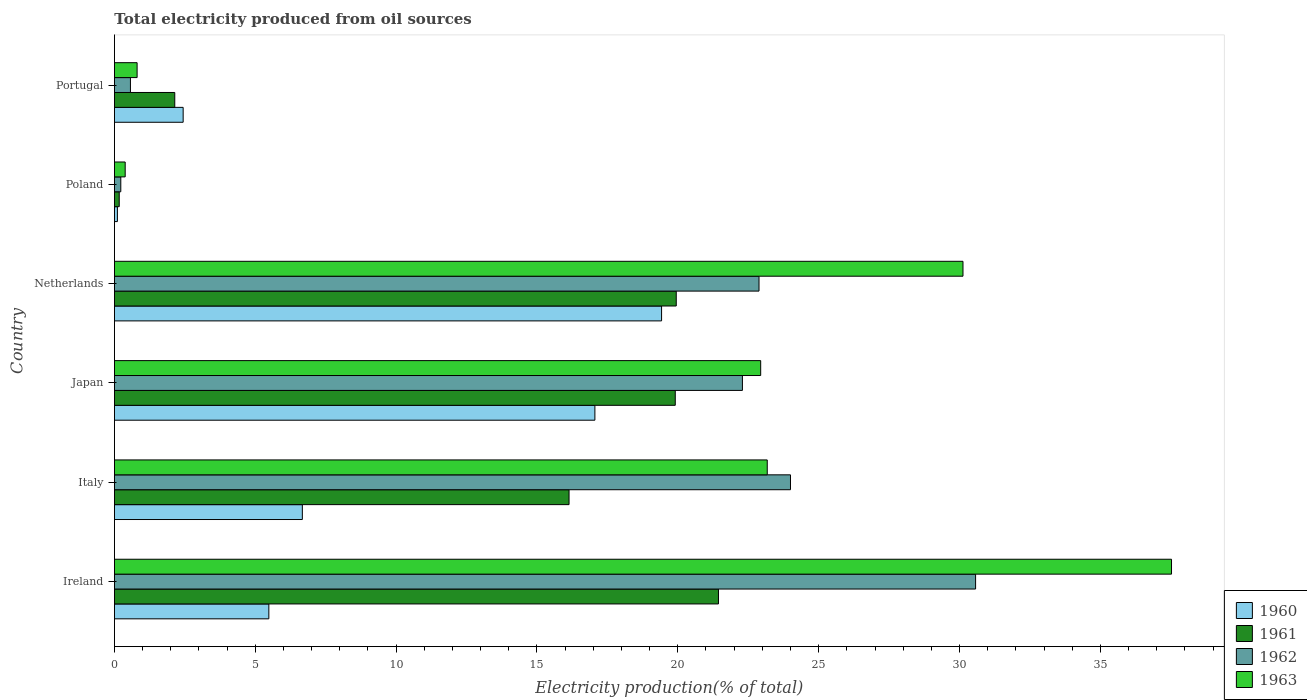How many different coloured bars are there?
Ensure brevity in your answer.  4. Are the number of bars on each tick of the Y-axis equal?
Ensure brevity in your answer.  Yes. What is the total electricity produced in 1962 in Ireland?
Ensure brevity in your answer.  30.57. Across all countries, what is the maximum total electricity produced in 1963?
Offer a very short reply. 37.53. Across all countries, what is the minimum total electricity produced in 1961?
Your answer should be compact. 0.17. In which country was the total electricity produced in 1962 maximum?
Give a very brief answer. Ireland. In which country was the total electricity produced in 1962 minimum?
Give a very brief answer. Poland. What is the total total electricity produced in 1963 in the graph?
Your response must be concise. 114.95. What is the difference between the total electricity produced in 1962 in Italy and that in Netherlands?
Offer a very short reply. 1.12. What is the difference between the total electricity produced in 1960 in Ireland and the total electricity produced in 1963 in Italy?
Offer a very short reply. -17.69. What is the average total electricity produced in 1961 per country?
Your response must be concise. 13.29. What is the difference between the total electricity produced in 1963 and total electricity produced in 1960 in Italy?
Give a very brief answer. 16.5. What is the ratio of the total electricity produced in 1961 in Ireland to that in Japan?
Keep it short and to the point. 1.08. What is the difference between the highest and the second highest total electricity produced in 1961?
Give a very brief answer. 1.5. What is the difference between the highest and the lowest total electricity produced in 1963?
Your response must be concise. 37.14. Is it the case that in every country, the sum of the total electricity produced in 1960 and total electricity produced in 1961 is greater than the total electricity produced in 1963?
Provide a short and direct response. No. How many bars are there?
Ensure brevity in your answer.  24. Are all the bars in the graph horizontal?
Provide a succinct answer. Yes. What is the difference between two consecutive major ticks on the X-axis?
Give a very brief answer. 5. How many legend labels are there?
Your response must be concise. 4. How are the legend labels stacked?
Your answer should be very brief. Vertical. What is the title of the graph?
Provide a short and direct response. Total electricity produced from oil sources. What is the Electricity production(% of total) of 1960 in Ireland?
Your answer should be very brief. 5.48. What is the Electricity production(% of total) in 1961 in Ireland?
Your answer should be very brief. 21.44. What is the Electricity production(% of total) in 1962 in Ireland?
Give a very brief answer. 30.57. What is the Electricity production(% of total) of 1963 in Ireland?
Offer a very short reply. 37.53. What is the Electricity production(% of total) in 1960 in Italy?
Keep it short and to the point. 6.67. What is the Electricity production(% of total) in 1961 in Italy?
Provide a succinct answer. 16.14. What is the Electricity production(% of total) of 1962 in Italy?
Ensure brevity in your answer.  24. What is the Electricity production(% of total) in 1963 in Italy?
Provide a succinct answer. 23.17. What is the Electricity production(% of total) in 1960 in Japan?
Make the answer very short. 17.06. What is the Electricity production(% of total) of 1961 in Japan?
Your answer should be compact. 19.91. What is the Electricity production(% of total) in 1962 in Japan?
Provide a short and direct response. 22.29. What is the Electricity production(% of total) of 1963 in Japan?
Provide a succinct answer. 22.94. What is the Electricity production(% of total) of 1960 in Netherlands?
Give a very brief answer. 19.42. What is the Electricity production(% of total) in 1961 in Netherlands?
Provide a short and direct response. 19.94. What is the Electricity production(% of total) in 1962 in Netherlands?
Offer a terse response. 22.88. What is the Electricity production(% of total) of 1963 in Netherlands?
Your answer should be very brief. 30.12. What is the Electricity production(% of total) in 1960 in Poland?
Make the answer very short. 0.11. What is the Electricity production(% of total) of 1961 in Poland?
Offer a very short reply. 0.17. What is the Electricity production(% of total) of 1962 in Poland?
Keep it short and to the point. 0.23. What is the Electricity production(% of total) of 1963 in Poland?
Offer a terse response. 0.38. What is the Electricity production(% of total) in 1960 in Portugal?
Your response must be concise. 2.44. What is the Electricity production(% of total) of 1961 in Portugal?
Keep it short and to the point. 2.14. What is the Electricity production(% of total) of 1962 in Portugal?
Your response must be concise. 0.57. What is the Electricity production(% of total) in 1963 in Portugal?
Offer a terse response. 0.81. Across all countries, what is the maximum Electricity production(% of total) of 1960?
Keep it short and to the point. 19.42. Across all countries, what is the maximum Electricity production(% of total) of 1961?
Your answer should be compact. 21.44. Across all countries, what is the maximum Electricity production(% of total) of 1962?
Ensure brevity in your answer.  30.57. Across all countries, what is the maximum Electricity production(% of total) in 1963?
Keep it short and to the point. 37.53. Across all countries, what is the minimum Electricity production(% of total) in 1960?
Offer a terse response. 0.11. Across all countries, what is the minimum Electricity production(% of total) in 1961?
Your answer should be compact. 0.17. Across all countries, what is the minimum Electricity production(% of total) in 1962?
Provide a succinct answer. 0.23. Across all countries, what is the minimum Electricity production(% of total) of 1963?
Your answer should be compact. 0.38. What is the total Electricity production(% of total) in 1960 in the graph?
Ensure brevity in your answer.  51.18. What is the total Electricity production(% of total) of 1961 in the graph?
Provide a succinct answer. 79.75. What is the total Electricity production(% of total) in 1962 in the graph?
Your response must be concise. 100.54. What is the total Electricity production(% of total) in 1963 in the graph?
Provide a succinct answer. 114.95. What is the difference between the Electricity production(% of total) in 1960 in Ireland and that in Italy?
Give a very brief answer. -1.19. What is the difference between the Electricity production(% of total) in 1961 in Ireland and that in Italy?
Provide a short and direct response. 5.3. What is the difference between the Electricity production(% of total) in 1962 in Ireland and that in Italy?
Your answer should be compact. 6.57. What is the difference between the Electricity production(% of total) in 1963 in Ireland and that in Italy?
Make the answer very short. 14.35. What is the difference between the Electricity production(% of total) in 1960 in Ireland and that in Japan?
Offer a very short reply. -11.57. What is the difference between the Electricity production(% of total) in 1961 in Ireland and that in Japan?
Make the answer very short. 1.53. What is the difference between the Electricity production(% of total) in 1962 in Ireland and that in Japan?
Offer a very short reply. 8.28. What is the difference between the Electricity production(% of total) in 1963 in Ireland and that in Japan?
Your response must be concise. 14.58. What is the difference between the Electricity production(% of total) in 1960 in Ireland and that in Netherlands?
Provide a short and direct response. -13.94. What is the difference between the Electricity production(% of total) in 1961 in Ireland and that in Netherlands?
Offer a very short reply. 1.5. What is the difference between the Electricity production(% of total) in 1962 in Ireland and that in Netherlands?
Your response must be concise. 7.69. What is the difference between the Electricity production(% of total) in 1963 in Ireland and that in Netherlands?
Make the answer very short. 7.4. What is the difference between the Electricity production(% of total) of 1960 in Ireland and that in Poland?
Provide a short and direct response. 5.38. What is the difference between the Electricity production(% of total) of 1961 in Ireland and that in Poland?
Your answer should be compact. 21.27. What is the difference between the Electricity production(% of total) in 1962 in Ireland and that in Poland?
Make the answer very short. 30.34. What is the difference between the Electricity production(% of total) in 1963 in Ireland and that in Poland?
Offer a terse response. 37.14. What is the difference between the Electricity production(% of total) in 1960 in Ireland and that in Portugal?
Offer a terse response. 3.04. What is the difference between the Electricity production(% of total) in 1961 in Ireland and that in Portugal?
Make the answer very short. 19.3. What is the difference between the Electricity production(% of total) in 1962 in Ireland and that in Portugal?
Offer a very short reply. 30. What is the difference between the Electricity production(% of total) of 1963 in Ireland and that in Portugal?
Your response must be concise. 36.72. What is the difference between the Electricity production(% of total) in 1960 in Italy and that in Japan?
Your answer should be very brief. -10.39. What is the difference between the Electricity production(% of total) in 1961 in Italy and that in Japan?
Keep it short and to the point. -3.77. What is the difference between the Electricity production(% of total) in 1962 in Italy and that in Japan?
Ensure brevity in your answer.  1.71. What is the difference between the Electricity production(% of total) of 1963 in Italy and that in Japan?
Your answer should be very brief. 0.23. What is the difference between the Electricity production(% of total) in 1960 in Italy and that in Netherlands?
Your answer should be compact. -12.75. What is the difference between the Electricity production(% of total) in 1961 in Italy and that in Netherlands?
Provide a short and direct response. -3.81. What is the difference between the Electricity production(% of total) of 1962 in Italy and that in Netherlands?
Provide a succinct answer. 1.12. What is the difference between the Electricity production(% of total) of 1963 in Italy and that in Netherlands?
Provide a succinct answer. -6.95. What is the difference between the Electricity production(% of total) in 1960 in Italy and that in Poland?
Give a very brief answer. 6.57. What is the difference between the Electricity production(% of total) of 1961 in Italy and that in Poland?
Provide a short and direct response. 15.97. What is the difference between the Electricity production(% of total) in 1962 in Italy and that in Poland?
Your answer should be very brief. 23.77. What is the difference between the Electricity production(% of total) in 1963 in Italy and that in Poland?
Give a very brief answer. 22.79. What is the difference between the Electricity production(% of total) in 1960 in Italy and that in Portugal?
Your answer should be compact. 4.23. What is the difference between the Electricity production(% of total) of 1961 in Italy and that in Portugal?
Your answer should be compact. 14. What is the difference between the Electricity production(% of total) in 1962 in Italy and that in Portugal?
Your response must be concise. 23.43. What is the difference between the Electricity production(% of total) in 1963 in Italy and that in Portugal?
Provide a short and direct response. 22.37. What is the difference between the Electricity production(% of total) of 1960 in Japan and that in Netherlands?
Your answer should be very brief. -2.37. What is the difference between the Electricity production(% of total) in 1961 in Japan and that in Netherlands?
Make the answer very short. -0.04. What is the difference between the Electricity production(% of total) in 1962 in Japan and that in Netherlands?
Your answer should be compact. -0.59. What is the difference between the Electricity production(% of total) in 1963 in Japan and that in Netherlands?
Your answer should be compact. -7.18. What is the difference between the Electricity production(% of total) in 1960 in Japan and that in Poland?
Make the answer very short. 16.95. What is the difference between the Electricity production(% of total) in 1961 in Japan and that in Poland?
Provide a short and direct response. 19.74. What is the difference between the Electricity production(% of total) in 1962 in Japan and that in Poland?
Offer a very short reply. 22.07. What is the difference between the Electricity production(% of total) of 1963 in Japan and that in Poland?
Provide a short and direct response. 22.56. What is the difference between the Electricity production(% of total) of 1960 in Japan and that in Portugal?
Give a very brief answer. 14.62. What is the difference between the Electricity production(% of total) in 1961 in Japan and that in Portugal?
Make the answer very short. 17.77. What is the difference between the Electricity production(% of total) of 1962 in Japan and that in Portugal?
Provide a succinct answer. 21.73. What is the difference between the Electricity production(% of total) in 1963 in Japan and that in Portugal?
Your response must be concise. 22.14. What is the difference between the Electricity production(% of total) of 1960 in Netherlands and that in Poland?
Provide a short and direct response. 19.32. What is the difference between the Electricity production(% of total) of 1961 in Netherlands and that in Poland?
Provide a succinct answer. 19.77. What is the difference between the Electricity production(% of total) of 1962 in Netherlands and that in Poland?
Your response must be concise. 22.66. What is the difference between the Electricity production(% of total) of 1963 in Netherlands and that in Poland?
Offer a terse response. 29.74. What is the difference between the Electricity production(% of total) in 1960 in Netherlands and that in Portugal?
Your response must be concise. 16.98. What is the difference between the Electricity production(% of total) in 1961 in Netherlands and that in Portugal?
Provide a succinct answer. 17.8. What is the difference between the Electricity production(% of total) of 1962 in Netherlands and that in Portugal?
Your response must be concise. 22.31. What is the difference between the Electricity production(% of total) in 1963 in Netherlands and that in Portugal?
Keep it short and to the point. 29.32. What is the difference between the Electricity production(% of total) in 1960 in Poland and that in Portugal?
Make the answer very short. -2.33. What is the difference between the Electricity production(% of total) in 1961 in Poland and that in Portugal?
Your answer should be compact. -1.97. What is the difference between the Electricity production(% of total) in 1962 in Poland and that in Portugal?
Make the answer very short. -0.34. What is the difference between the Electricity production(% of total) in 1963 in Poland and that in Portugal?
Offer a very short reply. -0.42. What is the difference between the Electricity production(% of total) in 1960 in Ireland and the Electricity production(% of total) in 1961 in Italy?
Offer a terse response. -10.66. What is the difference between the Electricity production(% of total) in 1960 in Ireland and the Electricity production(% of total) in 1962 in Italy?
Offer a very short reply. -18.52. What is the difference between the Electricity production(% of total) of 1960 in Ireland and the Electricity production(% of total) of 1963 in Italy?
Ensure brevity in your answer.  -17.69. What is the difference between the Electricity production(% of total) of 1961 in Ireland and the Electricity production(% of total) of 1962 in Italy?
Offer a terse response. -2.56. What is the difference between the Electricity production(% of total) in 1961 in Ireland and the Electricity production(% of total) in 1963 in Italy?
Your answer should be very brief. -1.73. What is the difference between the Electricity production(% of total) of 1962 in Ireland and the Electricity production(% of total) of 1963 in Italy?
Provide a short and direct response. 7.4. What is the difference between the Electricity production(% of total) of 1960 in Ireland and the Electricity production(% of total) of 1961 in Japan?
Your answer should be very brief. -14.43. What is the difference between the Electricity production(% of total) in 1960 in Ireland and the Electricity production(% of total) in 1962 in Japan?
Offer a terse response. -16.81. What is the difference between the Electricity production(% of total) in 1960 in Ireland and the Electricity production(% of total) in 1963 in Japan?
Ensure brevity in your answer.  -17.46. What is the difference between the Electricity production(% of total) in 1961 in Ireland and the Electricity production(% of total) in 1962 in Japan?
Provide a short and direct response. -0.85. What is the difference between the Electricity production(% of total) in 1961 in Ireland and the Electricity production(% of total) in 1963 in Japan?
Give a very brief answer. -1.5. What is the difference between the Electricity production(% of total) in 1962 in Ireland and the Electricity production(% of total) in 1963 in Japan?
Give a very brief answer. 7.63. What is the difference between the Electricity production(% of total) of 1960 in Ireland and the Electricity production(% of total) of 1961 in Netherlands?
Keep it short and to the point. -14.46. What is the difference between the Electricity production(% of total) in 1960 in Ireland and the Electricity production(% of total) in 1962 in Netherlands?
Offer a very short reply. -17.4. What is the difference between the Electricity production(% of total) in 1960 in Ireland and the Electricity production(% of total) in 1963 in Netherlands?
Ensure brevity in your answer.  -24.64. What is the difference between the Electricity production(% of total) of 1961 in Ireland and the Electricity production(% of total) of 1962 in Netherlands?
Your response must be concise. -1.44. What is the difference between the Electricity production(% of total) in 1961 in Ireland and the Electricity production(% of total) in 1963 in Netherlands?
Your response must be concise. -8.68. What is the difference between the Electricity production(% of total) in 1962 in Ireland and the Electricity production(% of total) in 1963 in Netherlands?
Make the answer very short. 0.45. What is the difference between the Electricity production(% of total) of 1960 in Ireland and the Electricity production(% of total) of 1961 in Poland?
Make the answer very short. 5.31. What is the difference between the Electricity production(% of total) of 1960 in Ireland and the Electricity production(% of total) of 1962 in Poland?
Provide a succinct answer. 5.26. What is the difference between the Electricity production(% of total) of 1960 in Ireland and the Electricity production(% of total) of 1963 in Poland?
Offer a very short reply. 5.1. What is the difference between the Electricity production(% of total) in 1961 in Ireland and the Electricity production(% of total) in 1962 in Poland?
Your response must be concise. 21.22. What is the difference between the Electricity production(% of total) in 1961 in Ireland and the Electricity production(% of total) in 1963 in Poland?
Make the answer very short. 21.06. What is the difference between the Electricity production(% of total) of 1962 in Ireland and the Electricity production(% of total) of 1963 in Poland?
Your answer should be compact. 30.19. What is the difference between the Electricity production(% of total) of 1960 in Ireland and the Electricity production(% of total) of 1961 in Portugal?
Make the answer very short. 3.34. What is the difference between the Electricity production(% of total) in 1960 in Ireland and the Electricity production(% of total) in 1962 in Portugal?
Keep it short and to the point. 4.91. What is the difference between the Electricity production(% of total) of 1960 in Ireland and the Electricity production(% of total) of 1963 in Portugal?
Give a very brief answer. 4.68. What is the difference between the Electricity production(% of total) of 1961 in Ireland and the Electricity production(% of total) of 1962 in Portugal?
Ensure brevity in your answer.  20.87. What is the difference between the Electricity production(% of total) in 1961 in Ireland and the Electricity production(% of total) in 1963 in Portugal?
Provide a short and direct response. 20.64. What is the difference between the Electricity production(% of total) in 1962 in Ireland and the Electricity production(% of total) in 1963 in Portugal?
Your answer should be very brief. 29.77. What is the difference between the Electricity production(% of total) in 1960 in Italy and the Electricity production(% of total) in 1961 in Japan?
Your response must be concise. -13.24. What is the difference between the Electricity production(% of total) of 1960 in Italy and the Electricity production(% of total) of 1962 in Japan?
Offer a very short reply. -15.62. What is the difference between the Electricity production(% of total) of 1960 in Italy and the Electricity production(% of total) of 1963 in Japan?
Provide a short and direct response. -16.27. What is the difference between the Electricity production(% of total) in 1961 in Italy and the Electricity production(% of total) in 1962 in Japan?
Provide a short and direct response. -6.15. What is the difference between the Electricity production(% of total) in 1961 in Italy and the Electricity production(% of total) in 1963 in Japan?
Your answer should be very brief. -6.8. What is the difference between the Electricity production(% of total) in 1962 in Italy and the Electricity production(% of total) in 1963 in Japan?
Provide a succinct answer. 1.06. What is the difference between the Electricity production(% of total) in 1960 in Italy and the Electricity production(% of total) in 1961 in Netherlands?
Give a very brief answer. -13.27. What is the difference between the Electricity production(% of total) of 1960 in Italy and the Electricity production(% of total) of 1962 in Netherlands?
Your answer should be very brief. -16.21. What is the difference between the Electricity production(% of total) of 1960 in Italy and the Electricity production(% of total) of 1963 in Netherlands?
Ensure brevity in your answer.  -23.45. What is the difference between the Electricity production(% of total) of 1961 in Italy and the Electricity production(% of total) of 1962 in Netherlands?
Provide a short and direct response. -6.74. What is the difference between the Electricity production(% of total) in 1961 in Italy and the Electricity production(% of total) in 1963 in Netherlands?
Your answer should be very brief. -13.98. What is the difference between the Electricity production(% of total) of 1962 in Italy and the Electricity production(% of total) of 1963 in Netherlands?
Your response must be concise. -6.12. What is the difference between the Electricity production(% of total) of 1960 in Italy and the Electricity production(% of total) of 1961 in Poland?
Make the answer very short. 6.5. What is the difference between the Electricity production(% of total) of 1960 in Italy and the Electricity production(% of total) of 1962 in Poland?
Keep it short and to the point. 6.44. What is the difference between the Electricity production(% of total) in 1960 in Italy and the Electricity production(% of total) in 1963 in Poland?
Provide a succinct answer. 6.29. What is the difference between the Electricity production(% of total) of 1961 in Italy and the Electricity production(% of total) of 1962 in Poland?
Ensure brevity in your answer.  15.91. What is the difference between the Electricity production(% of total) of 1961 in Italy and the Electricity production(% of total) of 1963 in Poland?
Ensure brevity in your answer.  15.76. What is the difference between the Electricity production(% of total) in 1962 in Italy and the Electricity production(% of total) in 1963 in Poland?
Your answer should be very brief. 23.62. What is the difference between the Electricity production(% of total) in 1960 in Italy and the Electricity production(% of total) in 1961 in Portugal?
Your answer should be very brief. 4.53. What is the difference between the Electricity production(% of total) in 1960 in Italy and the Electricity production(% of total) in 1962 in Portugal?
Your answer should be compact. 6.1. What is the difference between the Electricity production(% of total) of 1960 in Italy and the Electricity production(% of total) of 1963 in Portugal?
Provide a short and direct response. 5.87. What is the difference between the Electricity production(% of total) of 1961 in Italy and the Electricity production(% of total) of 1962 in Portugal?
Give a very brief answer. 15.57. What is the difference between the Electricity production(% of total) in 1961 in Italy and the Electricity production(% of total) in 1963 in Portugal?
Make the answer very short. 15.33. What is the difference between the Electricity production(% of total) in 1962 in Italy and the Electricity production(% of total) in 1963 in Portugal?
Provide a short and direct response. 23.19. What is the difference between the Electricity production(% of total) in 1960 in Japan and the Electricity production(% of total) in 1961 in Netherlands?
Provide a short and direct response. -2.89. What is the difference between the Electricity production(% of total) of 1960 in Japan and the Electricity production(% of total) of 1962 in Netherlands?
Ensure brevity in your answer.  -5.83. What is the difference between the Electricity production(% of total) of 1960 in Japan and the Electricity production(% of total) of 1963 in Netherlands?
Your response must be concise. -13.07. What is the difference between the Electricity production(% of total) of 1961 in Japan and the Electricity production(% of total) of 1962 in Netherlands?
Provide a succinct answer. -2.97. What is the difference between the Electricity production(% of total) of 1961 in Japan and the Electricity production(% of total) of 1963 in Netherlands?
Make the answer very short. -10.21. What is the difference between the Electricity production(% of total) of 1962 in Japan and the Electricity production(% of total) of 1963 in Netherlands?
Your answer should be compact. -7.83. What is the difference between the Electricity production(% of total) of 1960 in Japan and the Electricity production(% of total) of 1961 in Poland?
Make the answer very short. 16.89. What is the difference between the Electricity production(% of total) in 1960 in Japan and the Electricity production(% of total) in 1962 in Poland?
Provide a succinct answer. 16.83. What is the difference between the Electricity production(% of total) of 1960 in Japan and the Electricity production(% of total) of 1963 in Poland?
Your answer should be compact. 16.67. What is the difference between the Electricity production(% of total) of 1961 in Japan and the Electricity production(% of total) of 1962 in Poland?
Your response must be concise. 19.68. What is the difference between the Electricity production(% of total) in 1961 in Japan and the Electricity production(% of total) in 1963 in Poland?
Offer a very short reply. 19.53. What is the difference between the Electricity production(% of total) of 1962 in Japan and the Electricity production(% of total) of 1963 in Poland?
Make the answer very short. 21.91. What is the difference between the Electricity production(% of total) in 1960 in Japan and the Electricity production(% of total) in 1961 in Portugal?
Your answer should be compact. 14.91. What is the difference between the Electricity production(% of total) of 1960 in Japan and the Electricity production(% of total) of 1962 in Portugal?
Offer a very short reply. 16.49. What is the difference between the Electricity production(% of total) in 1960 in Japan and the Electricity production(% of total) in 1963 in Portugal?
Your response must be concise. 16.25. What is the difference between the Electricity production(% of total) of 1961 in Japan and the Electricity production(% of total) of 1962 in Portugal?
Provide a short and direct response. 19.34. What is the difference between the Electricity production(% of total) in 1961 in Japan and the Electricity production(% of total) in 1963 in Portugal?
Provide a short and direct response. 19.1. What is the difference between the Electricity production(% of total) of 1962 in Japan and the Electricity production(% of total) of 1963 in Portugal?
Your answer should be compact. 21.49. What is the difference between the Electricity production(% of total) in 1960 in Netherlands and the Electricity production(% of total) in 1961 in Poland?
Ensure brevity in your answer.  19.25. What is the difference between the Electricity production(% of total) of 1960 in Netherlands and the Electricity production(% of total) of 1962 in Poland?
Your answer should be very brief. 19.2. What is the difference between the Electricity production(% of total) in 1960 in Netherlands and the Electricity production(% of total) in 1963 in Poland?
Offer a very short reply. 19.04. What is the difference between the Electricity production(% of total) in 1961 in Netherlands and the Electricity production(% of total) in 1962 in Poland?
Give a very brief answer. 19.72. What is the difference between the Electricity production(% of total) in 1961 in Netherlands and the Electricity production(% of total) in 1963 in Poland?
Your answer should be compact. 19.56. What is the difference between the Electricity production(% of total) in 1962 in Netherlands and the Electricity production(% of total) in 1963 in Poland?
Ensure brevity in your answer.  22.5. What is the difference between the Electricity production(% of total) of 1960 in Netherlands and the Electricity production(% of total) of 1961 in Portugal?
Give a very brief answer. 17.28. What is the difference between the Electricity production(% of total) in 1960 in Netherlands and the Electricity production(% of total) in 1962 in Portugal?
Provide a succinct answer. 18.86. What is the difference between the Electricity production(% of total) in 1960 in Netherlands and the Electricity production(% of total) in 1963 in Portugal?
Provide a short and direct response. 18.62. What is the difference between the Electricity production(% of total) in 1961 in Netherlands and the Electricity production(% of total) in 1962 in Portugal?
Make the answer very short. 19.38. What is the difference between the Electricity production(% of total) of 1961 in Netherlands and the Electricity production(% of total) of 1963 in Portugal?
Provide a succinct answer. 19.14. What is the difference between the Electricity production(% of total) of 1962 in Netherlands and the Electricity production(% of total) of 1963 in Portugal?
Provide a succinct answer. 22.08. What is the difference between the Electricity production(% of total) of 1960 in Poland and the Electricity production(% of total) of 1961 in Portugal?
Provide a short and direct response. -2.04. What is the difference between the Electricity production(% of total) in 1960 in Poland and the Electricity production(% of total) in 1962 in Portugal?
Your response must be concise. -0.46. What is the difference between the Electricity production(% of total) in 1960 in Poland and the Electricity production(% of total) in 1963 in Portugal?
Give a very brief answer. -0.7. What is the difference between the Electricity production(% of total) in 1961 in Poland and the Electricity production(% of total) in 1962 in Portugal?
Keep it short and to the point. -0.4. What is the difference between the Electricity production(% of total) of 1961 in Poland and the Electricity production(% of total) of 1963 in Portugal?
Your response must be concise. -0.63. What is the difference between the Electricity production(% of total) of 1962 in Poland and the Electricity production(% of total) of 1963 in Portugal?
Ensure brevity in your answer.  -0.58. What is the average Electricity production(% of total) of 1960 per country?
Give a very brief answer. 8.53. What is the average Electricity production(% of total) in 1961 per country?
Ensure brevity in your answer.  13.29. What is the average Electricity production(% of total) of 1962 per country?
Keep it short and to the point. 16.76. What is the average Electricity production(% of total) of 1963 per country?
Give a very brief answer. 19.16. What is the difference between the Electricity production(% of total) in 1960 and Electricity production(% of total) in 1961 in Ireland?
Give a very brief answer. -15.96. What is the difference between the Electricity production(% of total) in 1960 and Electricity production(% of total) in 1962 in Ireland?
Keep it short and to the point. -25.09. What is the difference between the Electricity production(% of total) of 1960 and Electricity production(% of total) of 1963 in Ireland?
Provide a short and direct response. -32.04. What is the difference between the Electricity production(% of total) in 1961 and Electricity production(% of total) in 1962 in Ireland?
Provide a succinct answer. -9.13. What is the difference between the Electricity production(% of total) of 1961 and Electricity production(% of total) of 1963 in Ireland?
Your answer should be compact. -16.08. What is the difference between the Electricity production(% of total) of 1962 and Electricity production(% of total) of 1963 in Ireland?
Provide a succinct answer. -6.95. What is the difference between the Electricity production(% of total) of 1960 and Electricity production(% of total) of 1961 in Italy?
Offer a very short reply. -9.47. What is the difference between the Electricity production(% of total) in 1960 and Electricity production(% of total) in 1962 in Italy?
Keep it short and to the point. -17.33. What is the difference between the Electricity production(% of total) in 1960 and Electricity production(% of total) in 1963 in Italy?
Make the answer very short. -16.5. What is the difference between the Electricity production(% of total) in 1961 and Electricity production(% of total) in 1962 in Italy?
Your response must be concise. -7.86. What is the difference between the Electricity production(% of total) in 1961 and Electricity production(% of total) in 1963 in Italy?
Make the answer very short. -7.04. What is the difference between the Electricity production(% of total) in 1962 and Electricity production(% of total) in 1963 in Italy?
Your answer should be compact. 0.83. What is the difference between the Electricity production(% of total) of 1960 and Electricity production(% of total) of 1961 in Japan?
Your answer should be very brief. -2.85. What is the difference between the Electricity production(% of total) of 1960 and Electricity production(% of total) of 1962 in Japan?
Your response must be concise. -5.24. What is the difference between the Electricity production(% of total) in 1960 and Electricity production(% of total) in 1963 in Japan?
Your answer should be very brief. -5.89. What is the difference between the Electricity production(% of total) of 1961 and Electricity production(% of total) of 1962 in Japan?
Your answer should be compact. -2.38. What is the difference between the Electricity production(% of total) of 1961 and Electricity production(% of total) of 1963 in Japan?
Provide a short and direct response. -3.03. What is the difference between the Electricity production(% of total) of 1962 and Electricity production(% of total) of 1963 in Japan?
Provide a short and direct response. -0.65. What is the difference between the Electricity production(% of total) in 1960 and Electricity production(% of total) in 1961 in Netherlands?
Offer a very short reply. -0.52. What is the difference between the Electricity production(% of total) of 1960 and Electricity production(% of total) of 1962 in Netherlands?
Ensure brevity in your answer.  -3.46. What is the difference between the Electricity production(% of total) in 1960 and Electricity production(% of total) in 1963 in Netherlands?
Your response must be concise. -10.7. What is the difference between the Electricity production(% of total) in 1961 and Electricity production(% of total) in 1962 in Netherlands?
Offer a very short reply. -2.94. What is the difference between the Electricity production(% of total) in 1961 and Electricity production(% of total) in 1963 in Netherlands?
Offer a terse response. -10.18. What is the difference between the Electricity production(% of total) of 1962 and Electricity production(% of total) of 1963 in Netherlands?
Give a very brief answer. -7.24. What is the difference between the Electricity production(% of total) of 1960 and Electricity production(% of total) of 1961 in Poland?
Offer a very short reply. -0.06. What is the difference between the Electricity production(% of total) in 1960 and Electricity production(% of total) in 1962 in Poland?
Your answer should be compact. -0.12. What is the difference between the Electricity production(% of total) of 1960 and Electricity production(% of total) of 1963 in Poland?
Give a very brief answer. -0.28. What is the difference between the Electricity production(% of total) of 1961 and Electricity production(% of total) of 1962 in Poland?
Your answer should be compact. -0.06. What is the difference between the Electricity production(% of total) of 1961 and Electricity production(% of total) of 1963 in Poland?
Provide a short and direct response. -0.21. What is the difference between the Electricity production(% of total) in 1962 and Electricity production(% of total) in 1963 in Poland?
Provide a short and direct response. -0.16. What is the difference between the Electricity production(% of total) of 1960 and Electricity production(% of total) of 1961 in Portugal?
Provide a short and direct response. 0.3. What is the difference between the Electricity production(% of total) in 1960 and Electricity production(% of total) in 1962 in Portugal?
Your answer should be very brief. 1.87. What is the difference between the Electricity production(% of total) in 1960 and Electricity production(% of total) in 1963 in Portugal?
Your answer should be compact. 1.63. What is the difference between the Electricity production(% of total) of 1961 and Electricity production(% of total) of 1962 in Portugal?
Provide a short and direct response. 1.57. What is the difference between the Electricity production(% of total) in 1961 and Electricity production(% of total) in 1963 in Portugal?
Keep it short and to the point. 1.34. What is the difference between the Electricity production(% of total) of 1962 and Electricity production(% of total) of 1963 in Portugal?
Provide a succinct answer. -0.24. What is the ratio of the Electricity production(% of total) of 1960 in Ireland to that in Italy?
Give a very brief answer. 0.82. What is the ratio of the Electricity production(% of total) in 1961 in Ireland to that in Italy?
Give a very brief answer. 1.33. What is the ratio of the Electricity production(% of total) in 1962 in Ireland to that in Italy?
Your answer should be compact. 1.27. What is the ratio of the Electricity production(% of total) of 1963 in Ireland to that in Italy?
Make the answer very short. 1.62. What is the ratio of the Electricity production(% of total) of 1960 in Ireland to that in Japan?
Offer a terse response. 0.32. What is the ratio of the Electricity production(% of total) of 1961 in Ireland to that in Japan?
Provide a succinct answer. 1.08. What is the ratio of the Electricity production(% of total) in 1962 in Ireland to that in Japan?
Ensure brevity in your answer.  1.37. What is the ratio of the Electricity production(% of total) in 1963 in Ireland to that in Japan?
Your answer should be very brief. 1.64. What is the ratio of the Electricity production(% of total) in 1960 in Ireland to that in Netherlands?
Offer a very short reply. 0.28. What is the ratio of the Electricity production(% of total) of 1961 in Ireland to that in Netherlands?
Provide a succinct answer. 1.08. What is the ratio of the Electricity production(% of total) of 1962 in Ireland to that in Netherlands?
Provide a succinct answer. 1.34. What is the ratio of the Electricity production(% of total) in 1963 in Ireland to that in Netherlands?
Give a very brief answer. 1.25. What is the ratio of the Electricity production(% of total) of 1960 in Ireland to that in Poland?
Your answer should be very brief. 51.78. What is the ratio of the Electricity production(% of total) in 1961 in Ireland to that in Poland?
Provide a succinct answer. 125.7. What is the ratio of the Electricity production(% of total) of 1962 in Ireland to that in Poland?
Provide a short and direct response. 135.14. What is the ratio of the Electricity production(% of total) in 1963 in Ireland to that in Poland?
Offer a terse response. 98.31. What is the ratio of the Electricity production(% of total) of 1960 in Ireland to that in Portugal?
Offer a terse response. 2.25. What is the ratio of the Electricity production(% of total) of 1961 in Ireland to that in Portugal?
Provide a succinct answer. 10.01. What is the ratio of the Electricity production(% of total) in 1962 in Ireland to that in Portugal?
Your answer should be compact. 53.8. What is the ratio of the Electricity production(% of total) of 1963 in Ireland to that in Portugal?
Provide a succinct answer. 46.6. What is the ratio of the Electricity production(% of total) in 1960 in Italy to that in Japan?
Keep it short and to the point. 0.39. What is the ratio of the Electricity production(% of total) in 1961 in Italy to that in Japan?
Ensure brevity in your answer.  0.81. What is the ratio of the Electricity production(% of total) in 1962 in Italy to that in Japan?
Ensure brevity in your answer.  1.08. What is the ratio of the Electricity production(% of total) in 1960 in Italy to that in Netherlands?
Make the answer very short. 0.34. What is the ratio of the Electricity production(% of total) of 1961 in Italy to that in Netherlands?
Keep it short and to the point. 0.81. What is the ratio of the Electricity production(% of total) of 1962 in Italy to that in Netherlands?
Provide a short and direct response. 1.05. What is the ratio of the Electricity production(% of total) of 1963 in Italy to that in Netherlands?
Your answer should be compact. 0.77. What is the ratio of the Electricity production(% of total) in 1960 in Italy to that in Poland?
Provide a succinct answer. 63.01. What is the ratio of the Electricity production(% of total) of 1961 in Italy to that in Poland?
Your response must be concise. 94.6. What is the ratio of the Electricity production(% of total) in 1962 in Italy to that in Poland?
Give a very brief answer. 106.09. What is the ratio of the Electricity production(% of total) of 1963 in Italy to that in Poland?
Keep it short and to the point. 60.72. What is the ratio of the Electricity production(% of total) of 1960 in Italy to that in Portugal?
Your answer should be very brief. 2.73. What is the ratio of the Electricity production(% of total) in 1961 in Italy to that in Portugal?
Keep it short and to the point. 7.54. What is the ratio of the Electricity production(% of total) of 1962 in Italy to that in Portugal?
Your response must be concise. 42.24. What is the ratio of the Electricity production(% of total) in 1963 in Italy to that in Portugal?
Offer a terse response. 28.78. What is the ratio of the Electricity production(% of total) of 1960 in Japan to that in Netherlands?
Offer a terse response. 0.88. What is the ratio of the Electricity production(% of total) of 1962 in Japan to that in Netherlands?
Provide a short and direct response. 0.97. What is the ratio of the Electricity production(% of total) of 1963 in Japan to that in Netherlands?
Provide a succinct answer. 0.76. What is the ratio of the Electricity production(% of total) in 1960 in Japan to that in Poland?
Your response must be concise. 161.11. What is the ratio of the Electricity production(% of total) in 1961 in Japan to that in Poland?
Give a very brief answer. 116.7. What is the ratio of the Electricity production(% of total) of 1962 in Japan to that in Poland?
Offer a terse response. 98.55. What is the ratio of the Electricity production(% of total) in 1963 in Japan to that in Poland?
Give a very brief answer. 60.11. What is the ratio of the Electricity production(% of total) of 1960 in Japan to that in Portugal?
Offer a terse response. 6.99. What is the ratio of the Electricity production(% of total) of 1961 in Japan to that in Portugal?
Keep it short and to the point. 9.3. What is the ratio of the Electricity production(% of total) in 1962 in Japan to that in Portugal?
Provide a short and direct response. 39.24. What is the ratio of the Electricity production(% of total) in 1963 in Japan to that in Portugal?
Offer a very short reply. 28.49. What is the ratio of the Electricity production(% of total) in 1960 in Netherlands to that in Poland?
Provide a succinct answer. 183.47. What is the ratio of the Electricity production(% of total) of 1961 in Netherlands to that in Poland?
Give a very brief answer. 116.91. What is the ratio of the Electricity production(% of total) in 1962 in Netherlands to that in Poland?
Make the answer very short. 101.15. What is the ratio of the Electricity production(% of total) of 1963 in Netherlands to that in Poland?
Provide a succinct answer. 78.92. What is the ratio of the Electricity production(% of total) in 1960 in Netherlands to that in Portugal?
Give a very brief answer. 7.96. What is the ratio of the Electricity production(% of total) in 1961 in Netherlands to that in Portugal?
Offer a very short reply. 9.31. What is the ratio of the Electricity production(% of total) in 1962 in Netherlands to that in Portugal?
Provide a succinct answer. 40.27. What is the ratio of the Electricity production(% of total) of 1963 in Netherlands to that in Portugal?
Make the answer very short. 37.4. What is the ratio of the Electricity production(% of total) in 1960 in Poland to that in Portugal?
Provide a short and direct response. 0.04. What is the ratio of the Electricity production(% of total) in 1961 in Poland to that in Portugal?
Your response must be concise. 0.08. What is the ratio of the Electricity production(% of total) in 1962 in Poland to that in Portugal?
Your answer should be compact. 0.4. What is the ratio of the Electricity production(% of total) of 1963 in Poland to that in Portugal?
Make the answer very short. 0.47. What is the difference between the highest and the second highest Electricity production(% of total) in 1960?
Keep it short and to the point. 2.37. What is the difference between the highest and the second highest Electricity production(% of total) of 1961?
Keep it short and to the point. 1.5. What is the difference between the highest and the second highest Electricity production(% of total) of 1962?
Ensure brevity in your answer.  6.57. What is the difference between the highest and the second highest Electricity production(% of total) of 1963?
Ensure brevity in your answer.  7.4. What is the difference between the highest and the lowest Electricity production(% of total) of 1960?
Give a very brief answer. 19.32. What is the difference between the highest and the lowest Electricity production(% of total) in 1961?
Provide a succinct answer. 21.27. What is the difference between the highest and the lowest Electricity production(% of total) in 1962?
Your answer should be compact. 30.34. What is the difference between the highest and the lowest Electricity production(% of total) in 1963?
Your response must be concise. 37.14. 